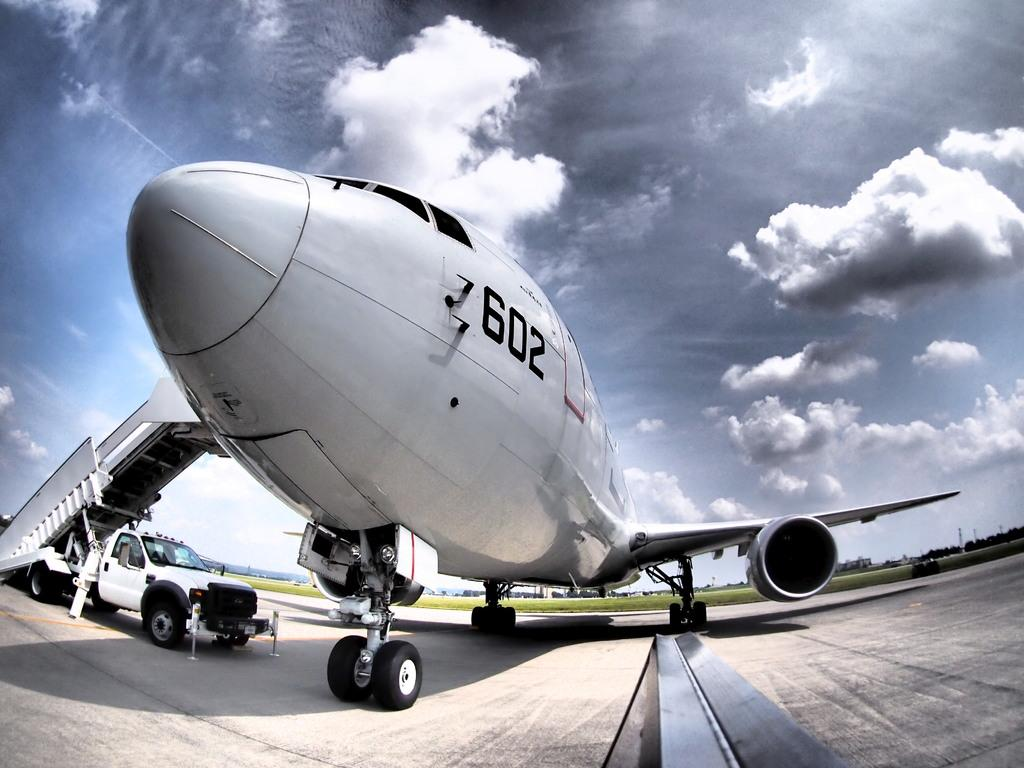<image>
Render a clear and concise summary of the photo. Plane number 602 is preparing for loading at the airport. 